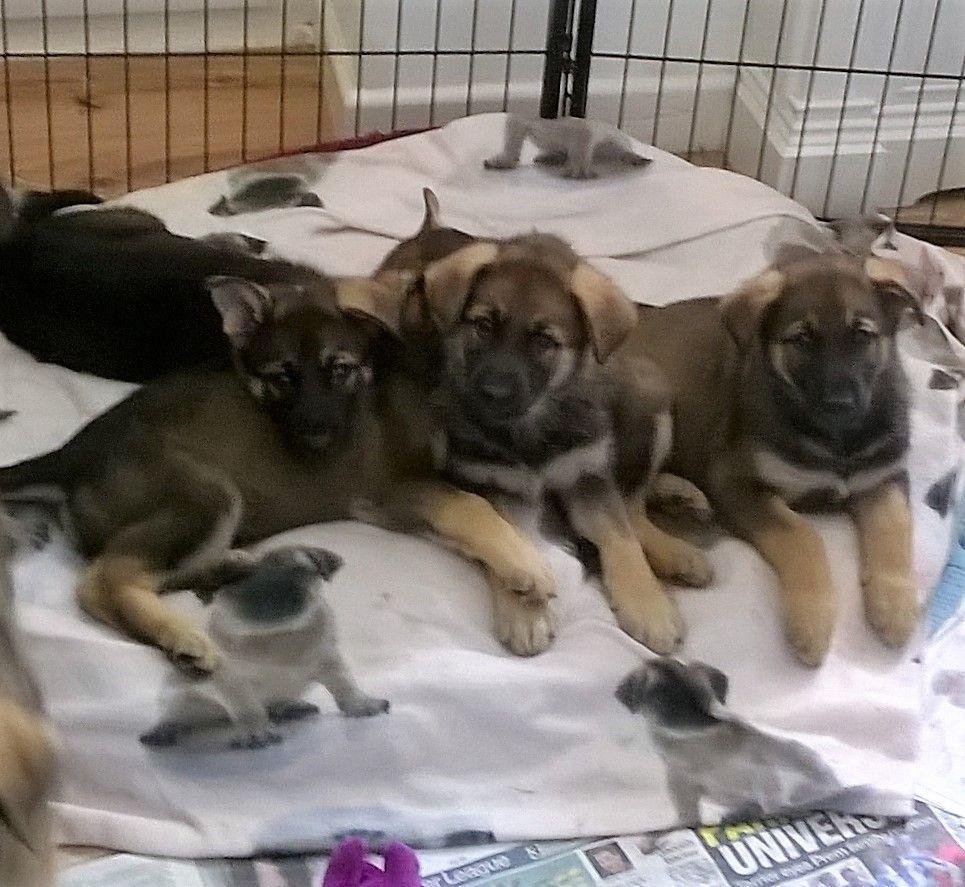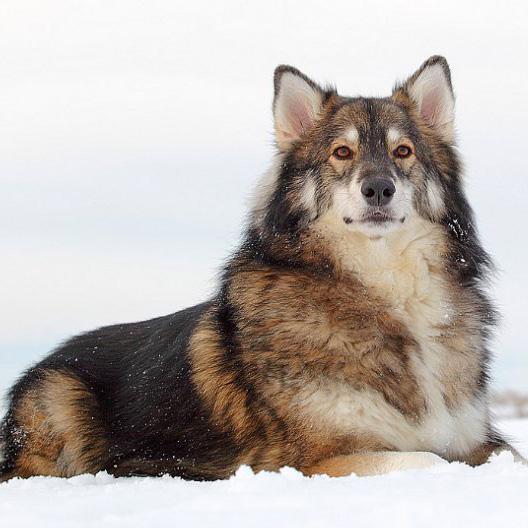The first image is the image on the left, the second image is the image on the right. Considering the images on both sides, is "Two dogs are in snow." valid? Answer yes or no. No. The first image is the image on the left, the second image is the image on the right. Analyze the images presented: Is the assertion "The left and right image contains the same number of dogs pointed in opposite directions." valid? Answer yes or no. No. 